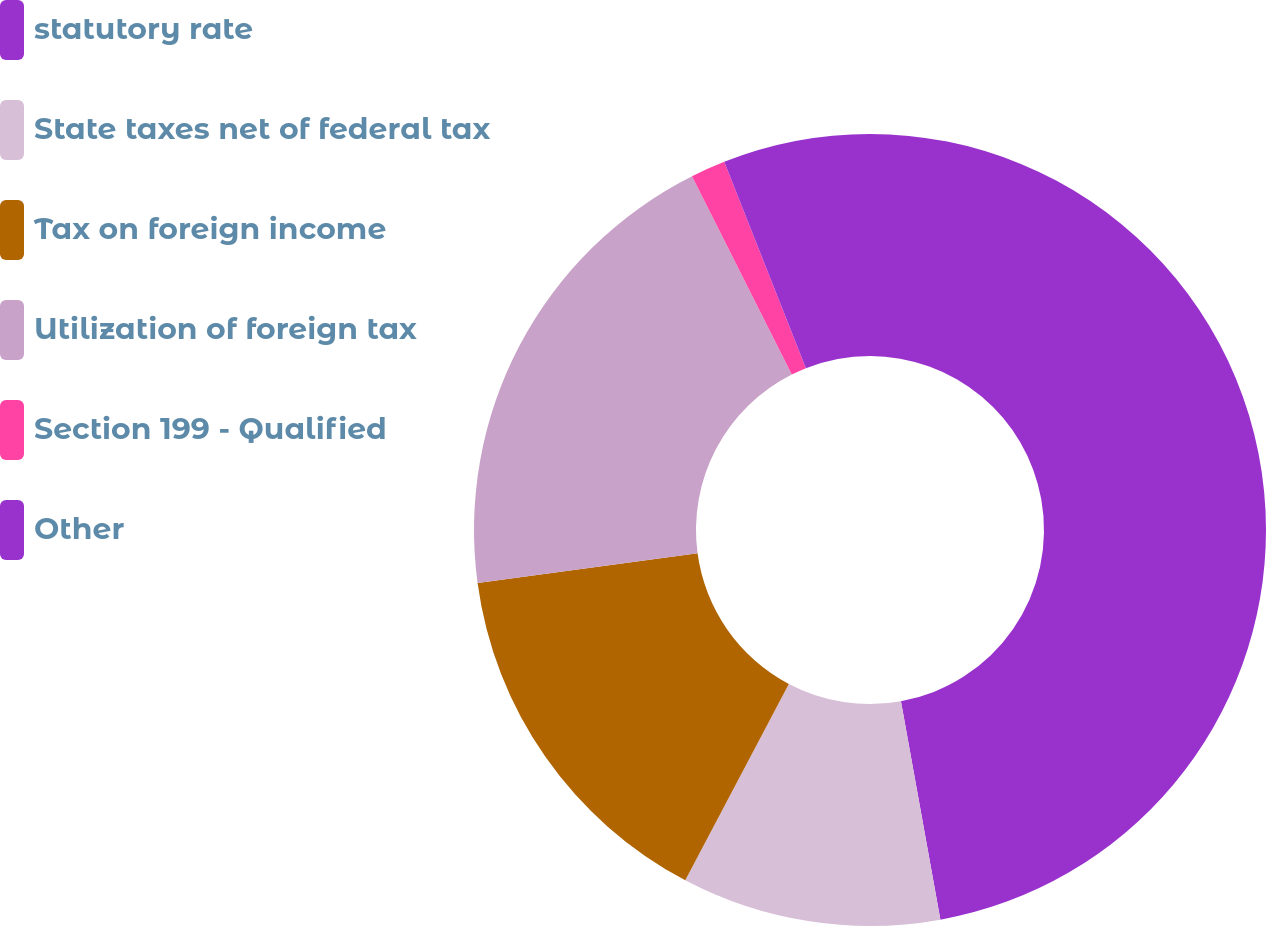<chart> <loc_0><loc_0><loc_500><loc_500><pie_chart><fcel>statutory rate<fcel>State taxes net of federal tax<fcel>Tax on foreign income<fcel>Utilization of foreign tax<fcel>Section 199 - Qualified<fcel>Other<nl><fcel>47.16%<fcel>10.57%<fcel>15.14%<fcel>19.72%<fcel>1.42%<fcel>6.0%<nl></chart> 